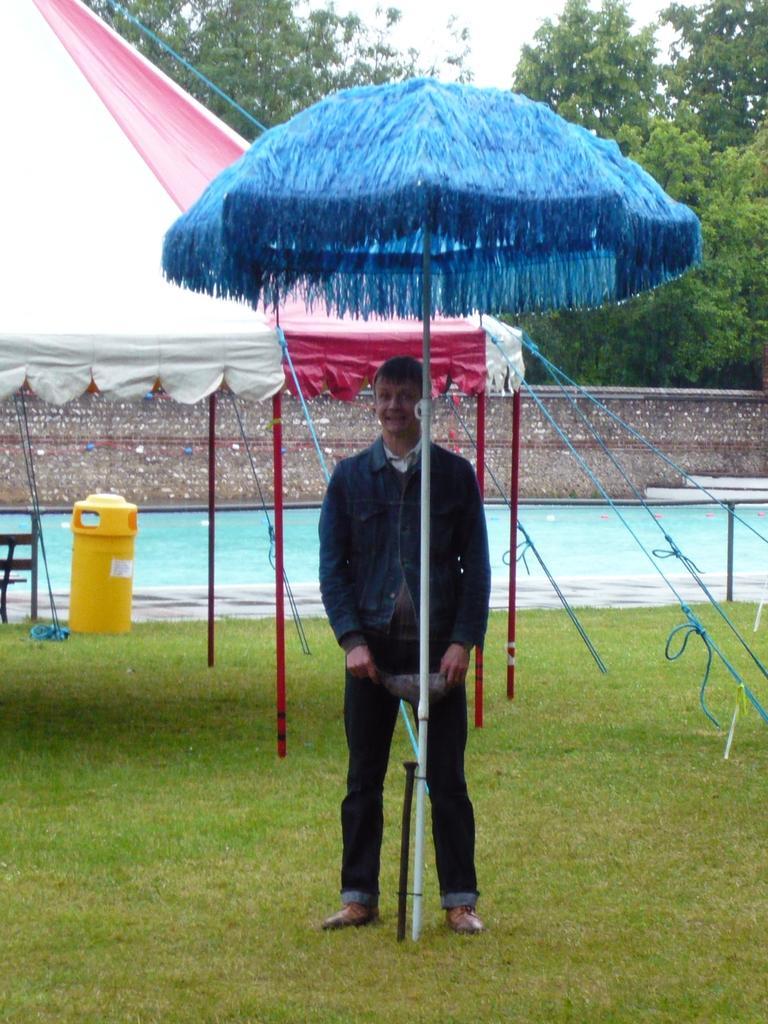Can you describe this image briefly? In this picture we can see a person on the ground, here we can see tents, grass, wall and some objects and in the background we can see trees, sky. 